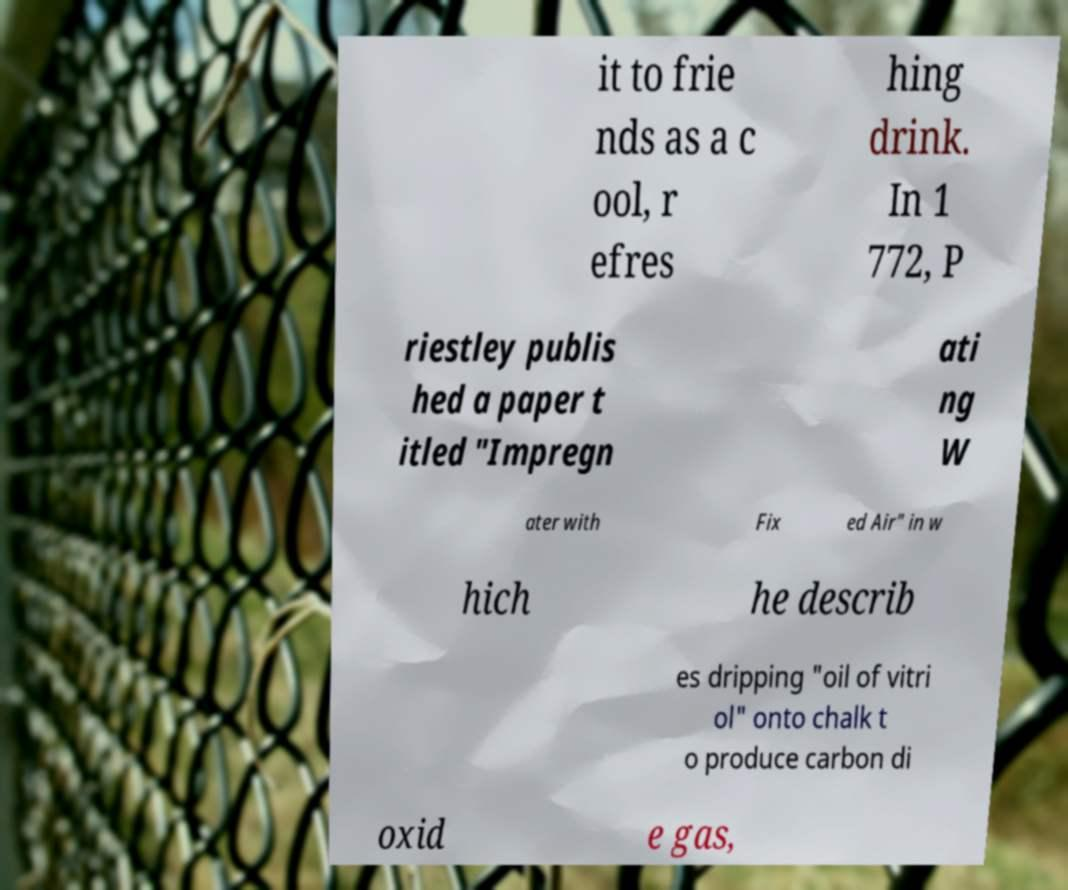Can you accurately transcribe the text from the provided image for me? it to frie nds as a c ool, r efres hing drink. In 1 772, P riestley publis hed a paper t itled "Impregn ati ng W ater with Fix ed Air" in w hich he describ es dripping "oil of vitri ol" onto chalk t o produce carbon di oxid e gas, 